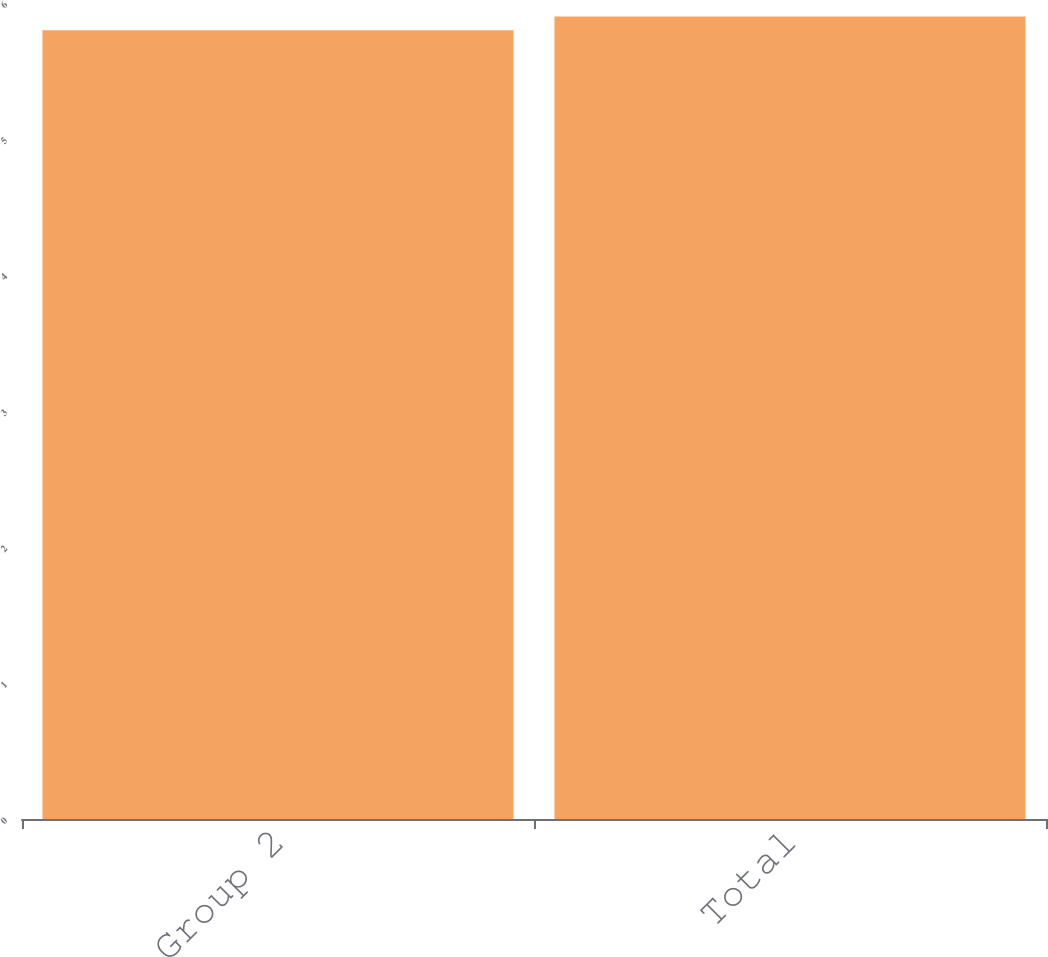Convert chart. <chart><loc_0><loc_0><loc_500><loc_500><bar_chart><fcel>Group 2<fcel>Total<nl><fcel>5.8<fcel>5.9<nl></chart> 